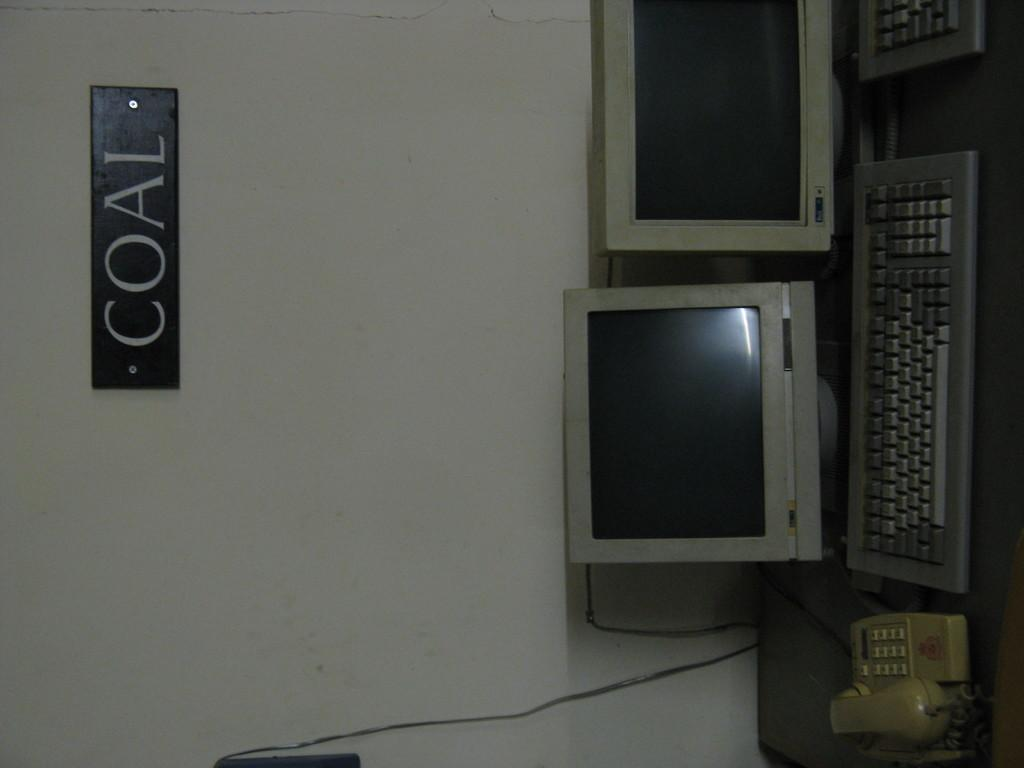<image>
Render a clear and concise summary of the photo. phone, some monitors and keyboards on a table and sign on wall that says coal 